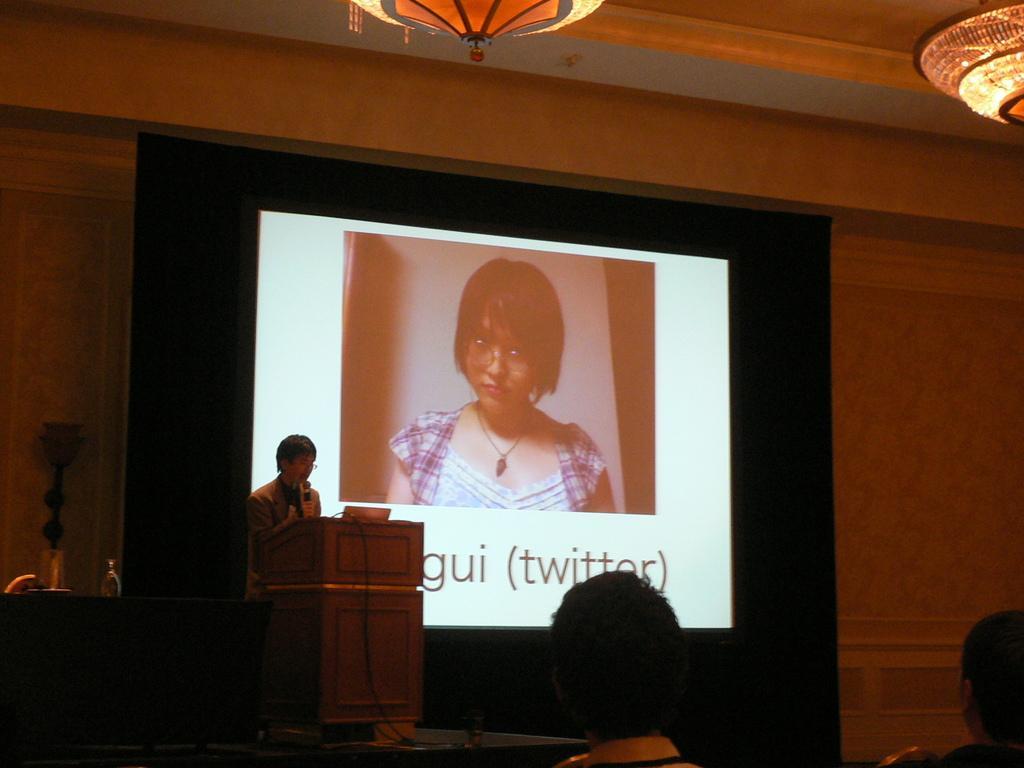Describe this image in one or two sentences. In this picture I can see 2 persons heads in front and in the middle of this picture I can see a podium and behind it I can see a person standing. In the background I can see the projector screen on which I can see a photo of a woman and I see something is written under the photo. On the top of this picture I can see the lights and on the left side of this picture I see few things. 